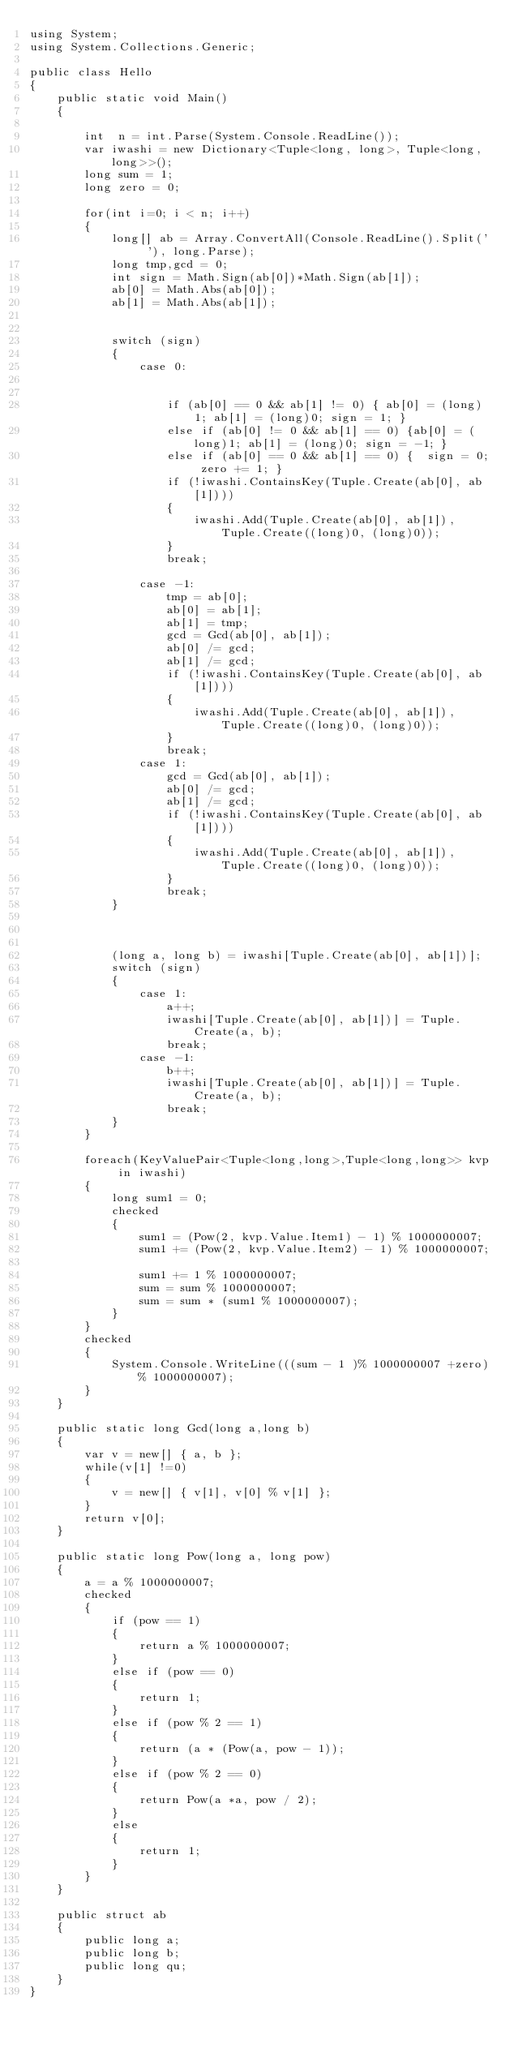Convert code to text. <code><loc_0><loc_0><loc_500><loc_500><_C#_>using System;
using System.Collections.Generic;

public class Hello
{
    public static void Main()
    {

        int  n = int.Parse(System.Console.ReadLine());
        var iwashi = new Dictionary<Tuple<long, long>, Tuple<long,long>>();
        long sum = 1;
        long zero = 0;

        for(int i=0; i < n; i++)
        {
            long[] ab = Array.ConvertAll(Console.ReadLine().Split(' '), long.Parse);
            long tmp,gcd = 0;
            int sign = Math.Sign(ab[0])*Math.Sign(ab[1]);
            ab[0] = Math.Abs(ab[0]);
            ab[1] = Math.Abs(ab[1]);


            switch (sign)
            {
                case 0:


                    if (ab[0] == 0 && ab[1] != 0) { ab[0] = (long)1; ab[1] = (long)0; sign = 1; }
                    else if (ab[0] != 0 && ab[1] == 0) {ab[0] = (long)1; ab[1] = (long)0; sign = -1; }
                    else if (ab[0] == 0 && ab[1] == 0) {  sign = 0; zero += 1; }
                    if (!iwashi.ContainsKey(Tuple.Create(ab[0], ab[1])))
                    {
                        iwashi.Add(Tuple.Create(ab[0], ab[1]), Tuple.Create((long)0, (long)0));
                    }
                    break;

                case -1:
                    tmp = ab[0];
                    ab[0] = ab[1];
                    ab[1] = tmp;
                    gcd = Gcd(ab[0], ab[1]);
                    ab[0] /= gcd;
                    ab[1] /= gcd;
                    if (!iwashi.ContainsKey(Tuple.Create(ab[0], ab[1])))
                    {
                        iwashi.Add(Tuple.Create(ab[0], ab[1]), Tuple.Create((long)0, (long)0));
                    }
                    break;
                case 1:
                    gcd = Gcd(ab[0], ab[1]);
                    ab[0] /= gcd;
                    ab[1] /= gcd;
                    if (!iwashi.ContainsKey(Tuple.Create(ab[0], ab[1])))
                    {
                        iwashi.Add(Tuple.Create(ab[0], ab[1]), Tuple.Create((long)0, (long)0));
                    }
                    break;
            }



            (long a, long b) = iwashi[Tuple.Create(ab[0], ab[1])];
            switch (sign)
            {
                case 1:
                    a++;
                    iwashi[Tuple.Create(ab[0], ab[1])] = Tuple.Create(a, b);
                    break;
                case -1:
                    b++;
                    iwashi[Tuple.Create(ab[0], ab[1])] = Tuple.Create(a, b);
                    break;
            }
        }
        
        foreach(KeyValuePair<Tuple<long,long>,Tuple<long,long>> kvp in iwashi)
        {
            long sum1 = 0;
            checked
            {
                sum1 = (Pow(2, kvp.Value.Item1) - 1) % 1000000007;
                sum1 += (Pow(2, kvp.Value.Item2) - 1) % 1000000007;
          
                sum1 += 1 % 1000000007;
                sum = sum % 1000000007;
                sum = sum * (sum1 % 1000000007);
            }
        }
        checked
        {
            System.Console.WriteLine(((sum - 1 )% 1000000007 +zero)% 1000000007);
        }
    }

    public static long Gcd(long a,long b)
    {
        var v = new[] { a, b };
        while(v[1] !=0)
        {
            v = new[] { v[1], v[0] % v[1] };
        }
        return v[0];
    }

    public static long Pow(long a, long pow)
    {
        a = a % 1000000007;
        checked
        {
            if (pow == 1)
            {
                return a % 1000000007;
            }
            else if (pow == 0)
            {
                return 1;
            }
            else if (pow % 2 == 1)
            {
                return (a * (Pow(a, pow - 1));
            }
            else if (pow % 2 == 0)
            {
                return Pow(a *a, pow / 2);
            }
            else
            {
                return 1;
            }
        }
    }

    public struct ab
    {
        public long a;
        public long b;
        public long qu;
    }
}</code> 